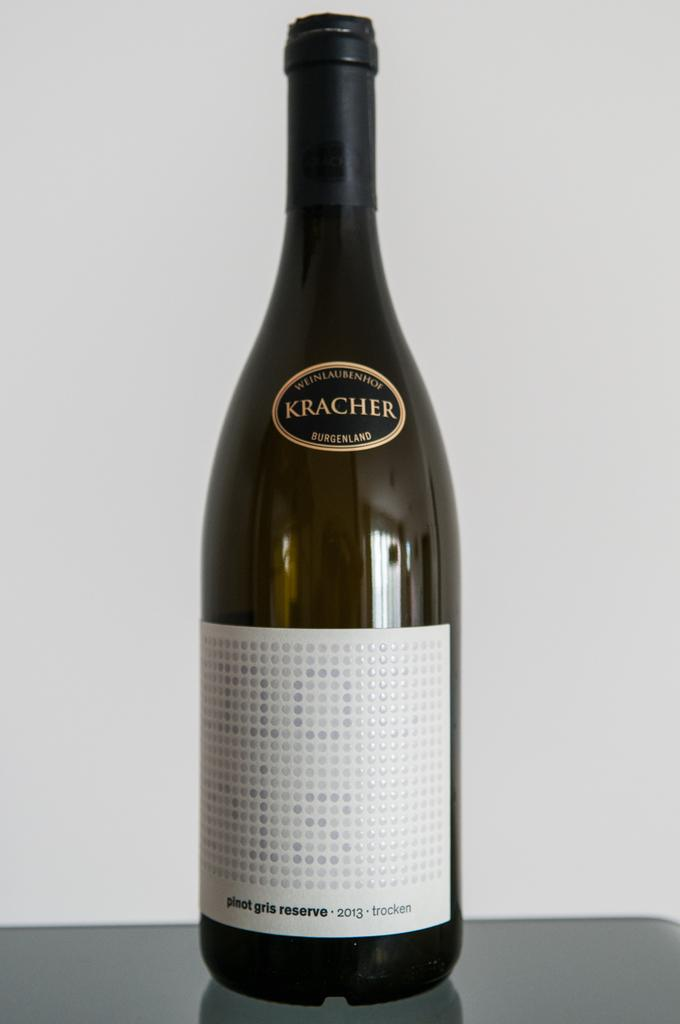Provide a one-sentence caption for the provided image. A Kracher wine bottle shows a white label. 